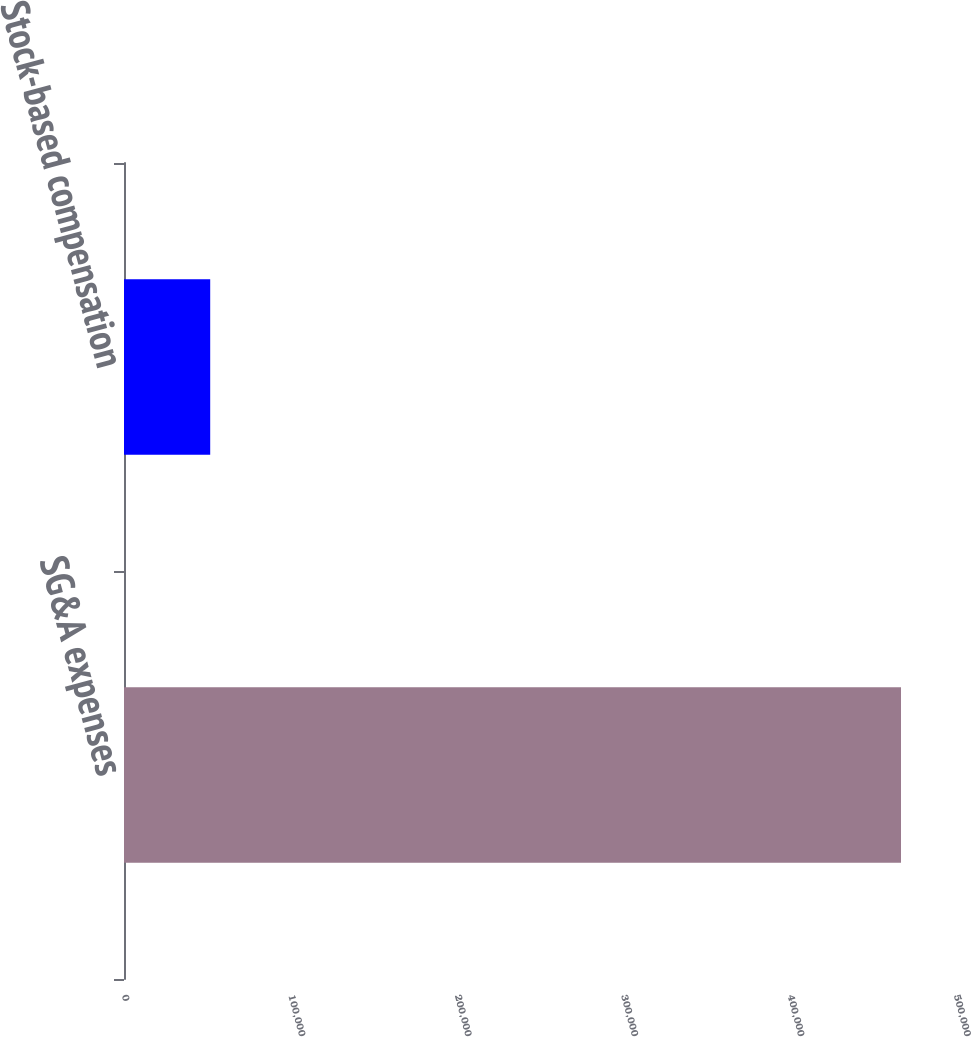Convert chart. <chart><loc_0><loc_0><loc_500><loc_500><bar_chart><fcel>SG&A expenses<fcel>Stock-based compensation<nl><fcel>466951<fcel>51806<nl></chart> 